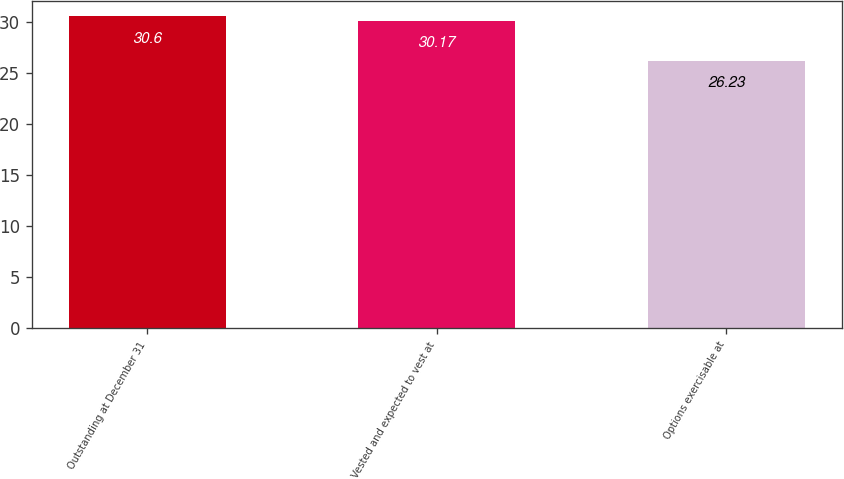<chart> <loc_0><loc_0><loc_500><loc_500><bar_chart><fcel>Outstanding at December 31<fcel>Vested and expected to vest at<fcel>Options exercisable at<nl><fcel>30.6<fcel>30.17<fcel>26.23<nl></chart> 